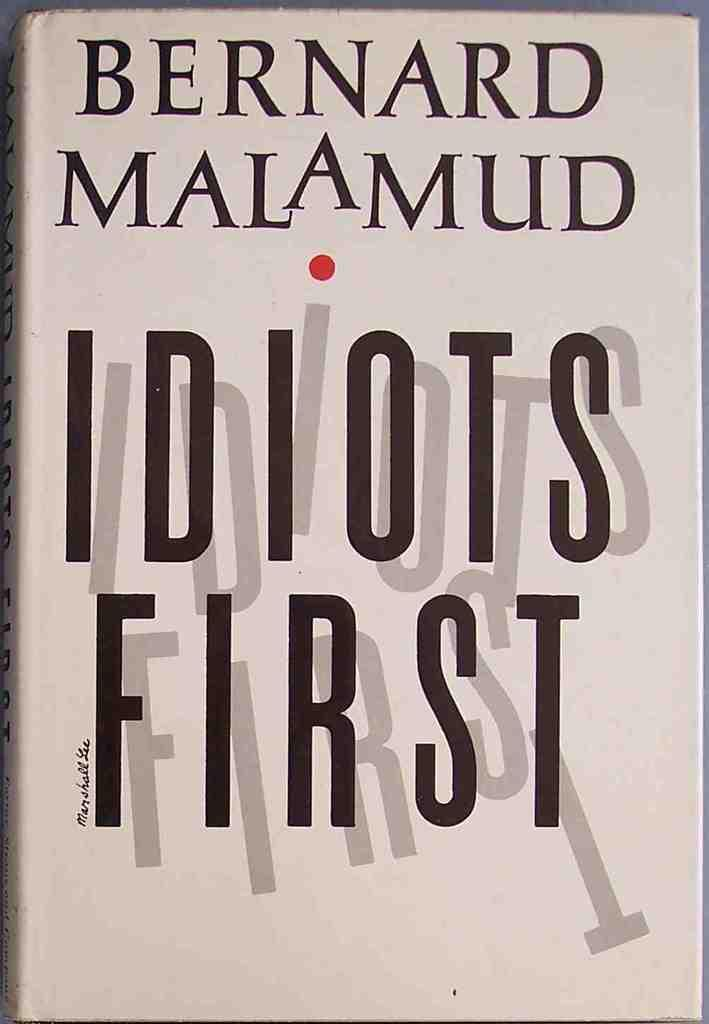<image>
Present a compact description of the photo's key features. Book cover for Idiots First by Bernard Malamud. 